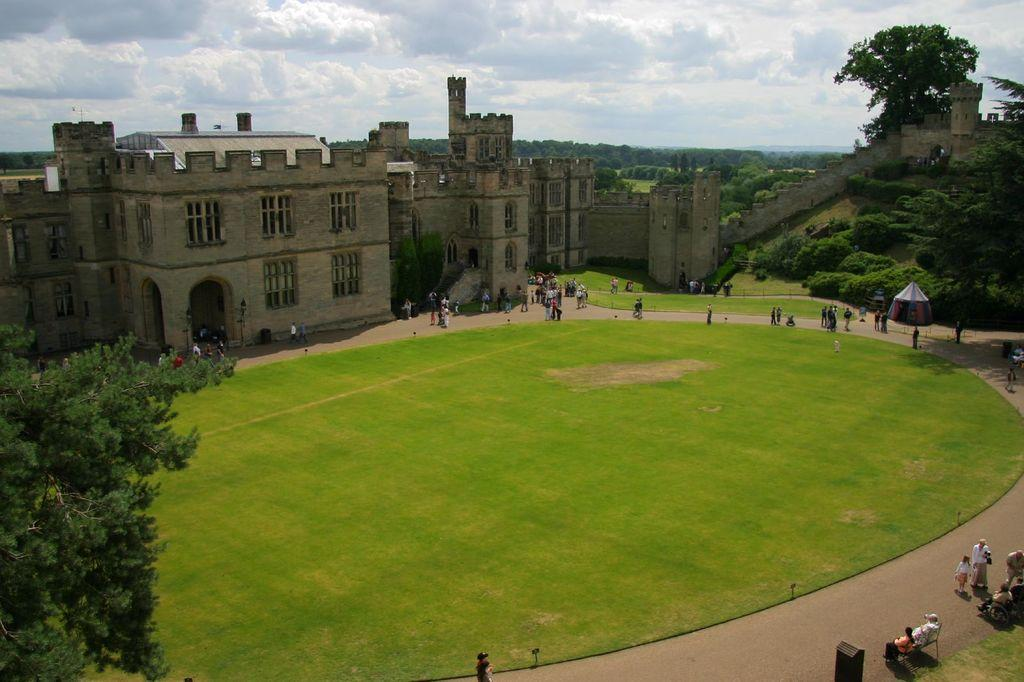What is the main structure visible in the image? There is a huge fort in the image. What is located in front of the fort? There is a big garden in front of the fort. What can be seen around the garden? Many people are standing around the garden. What type of vegetation surrounds the fort? There are many trees around the fort. How does the fort help reduce pollution in the image? The fort does not have any direct impact on pollution in the image; it is a historical structure surrounded by a garden and trees. 